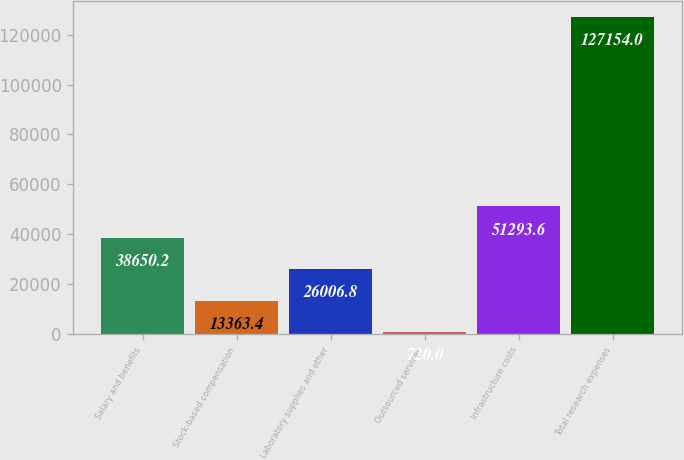<chart> <loc_0><loc_0><loc_500><loc_500><bar_chart><fcel>Salary and benefits<fcel>Stock-based compensation<fcel>Laboratory supplies and other<fcel>Outsourced services<fcel>Infrastructure costs<fcel>Total research expenses<nl><fcel>38650.2<fcel>13363.4<fcel>26006.8<fcel>720<fcel>51293.6<fcel>127154<nl></chart> 